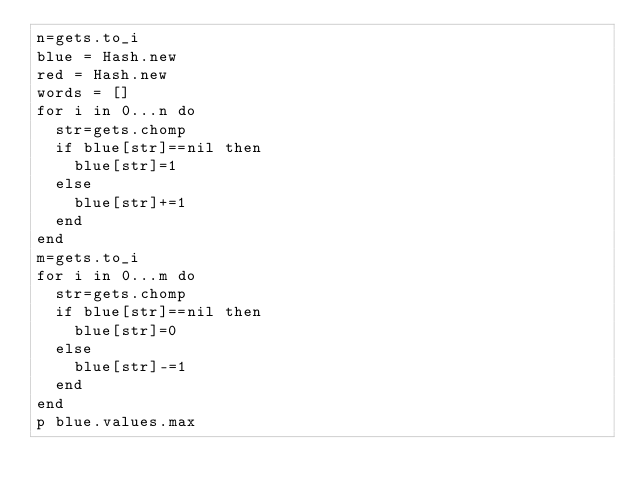<code> <loc_0><loc_0><loc_500><loc_500><_Ruby_>n=gets.to_i
blue = Hash.new
red = Hash.new
words = []
for i in 0...n do
  str=gets.chomp
  if blue[str]==nil then
    blue[str]=1
  else
    blue[str]+=1
  end
end
m=gets.to_i
for i in 0...m do
  str=gets.chomp
  if blue[str]==nil then
    blue[str]=0
  else
    blue[str]-=1
  end
end
p blue.values.max
</code> 